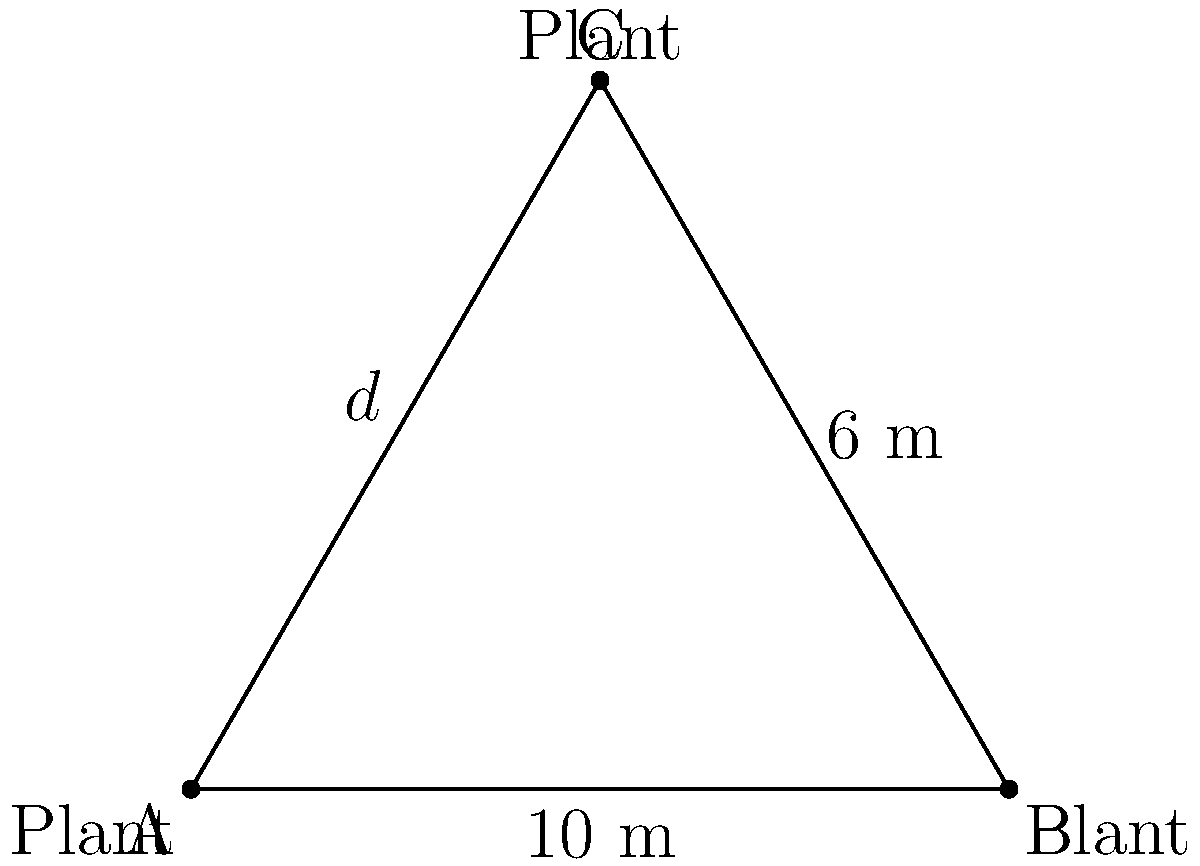In a triangular vineyard planting arrangement, two adjacent plants in a row are 10 meters apart, and the plant in the next row forms an isosceles triangle with these two plants. If the distance between the rows is 6 meters, what is the optimal distance $d$ (in meters) between plants within each row to maximize planting density? To solve this problem, we'll use the properties of isosceles triangles and the Pythagorean theorem:

1) In the triangle ABC, AB = 10 m (distance between plants in a row), and the height of the triangle (distance between rows) is 6 m.

2) Since it's an isosceles triangle, AC = BC = $d$ (the distance we're trying to find).

3) Let's split the triangle in half by drawing a line from C to the midpoint of AB. This creates two right triangles.

4) In one of these right triangles:
   - The base is half of AB, so 5 m
   - The height is 6 m
   - The hypotenuse is $d$

5) We can use the Pythagorean theorem:
   $d^2 = 5^2 + 6^2$

6) Simplify:
   $d^2 = 25 + 36 = 61$

7) Take the square root of both sides:
   $d = \sqrt{61}$

8) Simplify:
   $d \approx 7.81$ m

Therefore, the optimal distance between plants within each row is approximately 7.81 meters.
Answer: $\sqrt{61}$ m or approximately 7.81 m 